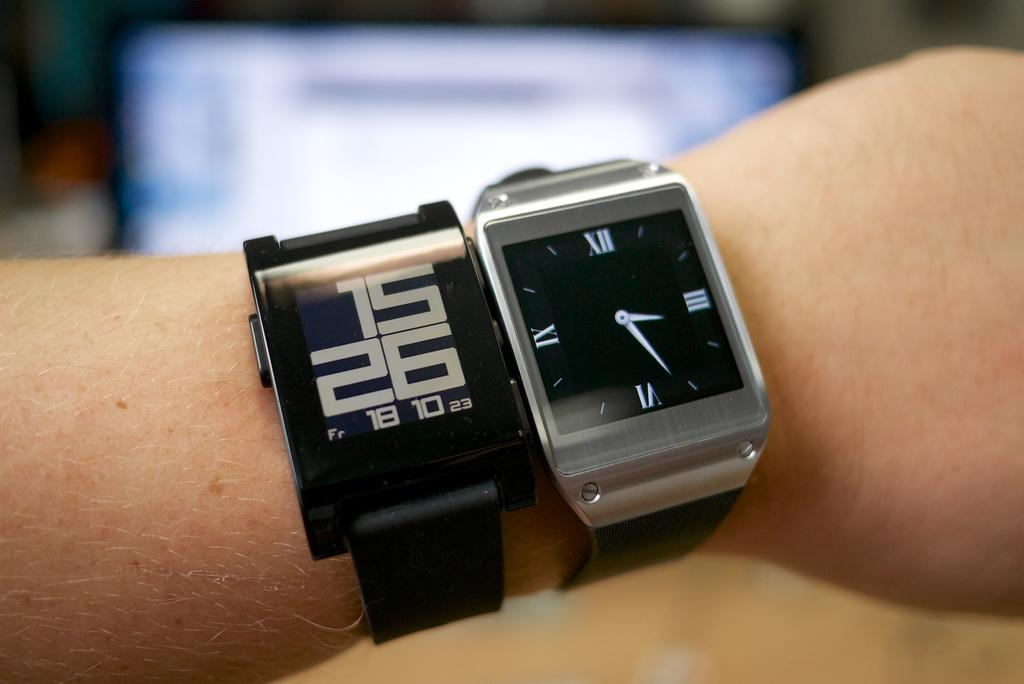<image>
Render a clear and concise summary of the photo. two watches, a digital and an analogue stating the time at 15.26. 